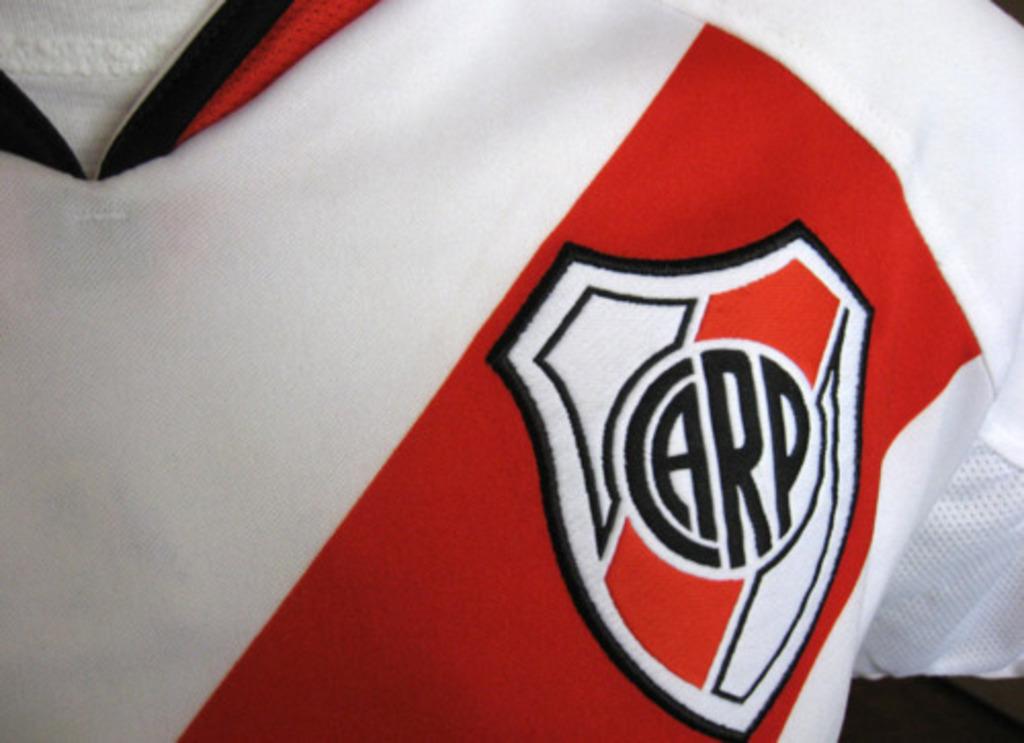What does the patch say?
Offer a terse response. Carp. 